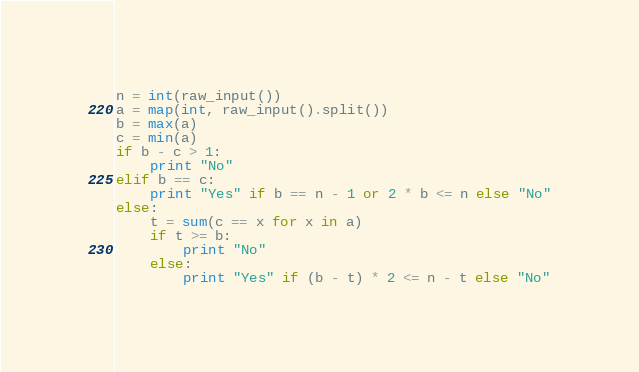<code> <loc_0><loc_0><loc_500><loc_500><_Python_>n = int(raw_input())
a = map(int, raw_input().split())
b = max(a)
c = min(a)
if b - c > 1:
    print "No"
elif b == c:
    print "Yes" if b == n - 1 or 2 * b <= n else "No"
else:
    t = sum(c == x for x in a)
    if t >= b:
        print "No"
    else:
        print "Yes" if (b - t) * 2 <= n - t else "No"
</code> 